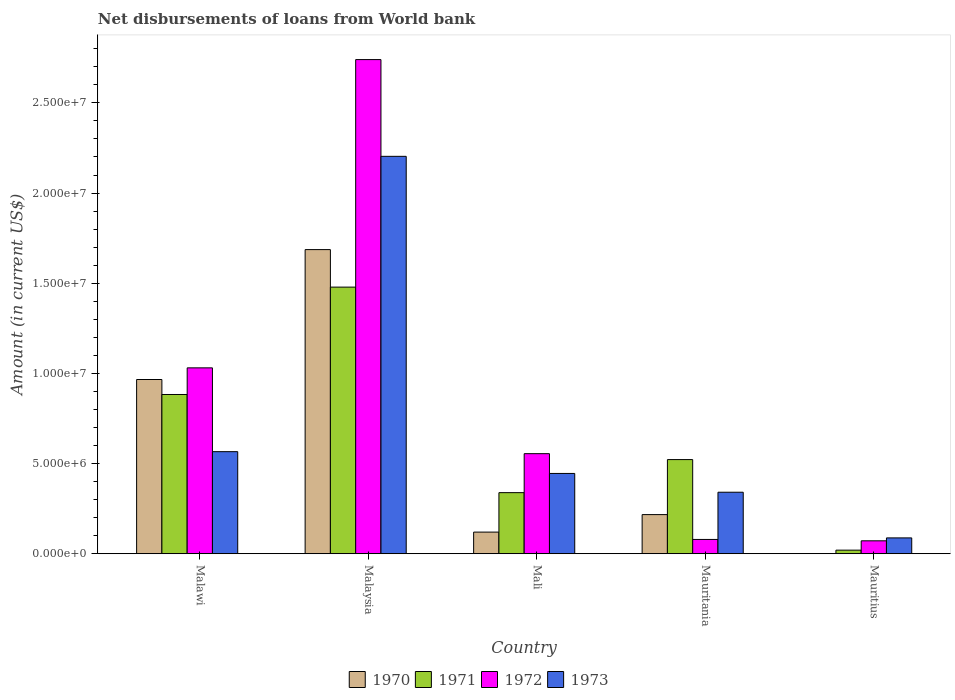Are the number of bars on each tick of the X-axis equal?
Offer a very short reply. No. How many bars are there on the 2nd tick from the left?
Provide a succinct answer. 4. How many bars are there on the 3rd tick from the right?
Keep it short and to the point. 4. What is the label of the 3rd group of bars from the left?
Your response must be concise. Mali. What is the amount of loan disbursed from World Bank in 1971 in Malaysia?
Provide a succinct answer. 1.48e+07. Across all countries, what is the maximum amount of loan disbursed from World Bank in 1972?
Provide a succinct answer. 2.74e+07. Across all countries, what is the minimum amount of loan disbursed from World Bank in 1970?
Offer a very short reply. 0. In which country was the amount of loan disbursed from World Bank in 1970 maximum?
Keep it short and to the point. Malaysia. What is the total amount of loan disbursed from World Bank in 1970 in the graph?
Offer a very short reply. 2.99e+07. What is the difference between the amount of loan disbursed from World Bank in 1970 in Malaysia and that in Mali?
Your answer should be very brief. 1.57e+07. What is the difference between the amount of loan disbursed from World Bank in 1971 in Mali and the amount of loan disbursed from World Bank in 1972 in Malawi?
Keep it short and to the point. -6.92e+06. What is the average amount of loan disbursed from World Bank in 1973 per country?
Make the answer very short. 7.29e+06. What is the difference between the amount of loan disbursed from World Bank of/in 1971 and amount of loan disbursed from World Bank of/in 1972 in Mauritius?
Ensure brevity in your answer.  -5.18e+05. In how many countries, is the amount of loan disbursed from World Bank in 1972 greater than 25000000 US$?
Provide a succinct answer. 1. What is the ratio of the amount of loan disbursed from World Bank in 1973 in Malawi to that in Mauritius?
Make the answer very short. 6.44. Is the amount of loan disbursed from World Bank in 1971 in Malaysia less than that in Mauritius?
Ensure brevity in your answer.  No. Is the difference between the amount of loan disbursed from World Bank in 1971 in Malaysia and Mauritania greater than the difference between the amount of loan disbursed from World Bank in 1972 in Malaysia and Mauritania?
Ensure brevity in your answer.  No. What is the difference between the highest and the second highest amount of loan disbursed from World Bank in 1972?
Your answer should be compact. 1.71e+07. What is the difference between the highest and the lowest amount of loan disbursed from World Bank in 1971?
Offer a very short reply. 1.46e+07. In how many countries, is the amount of loan disbursed from World Bank in 1972 greater than the average amount of loan disbursed from World Bank in 1972 taken over all countries?
Give a very brief answer. 2. Is it the case that in every country, the sum of the amount of loan disbursed from World Bank in 1971 and amount of loan disbursed from World Bank in 1970 is greater than the sum of amount of loan disbursed from World Bank in 1972 and amount of loan disbursed from World Bank in 1973?
Provide a succinct answer. No. Is it the case that in every country, the sum of the amount of loan disbursed from World Bank in 1970 and amount of loan disbursed from World Bank in 1972 is greater than the amount of loan disbursed from World Bank in 1973?
Offer a very short reply. No. Are all the bars in the graph horizontal?
Give a very brief answer. No. What is the difference between two consecutive major ticks on the Y-axis?
Your response must be concise. 5.00e+06. Does the graph contain any zero values?
Provide a short and direct response. Yes. Does the graph contain grids?
Provide a short and direct response. No. How are the legend labels stacked?
Your answer should be very brief. Horizontal. What is the title of the graph?
Keep it short and to the point. Net disbursements of loans from World bank. What is the label or title of the X-axis?
Give a very brief answer. Country. What is the label or title of the Y-axis?
Offer a terse response. Amount (in current US$). What is the Amount (in current US$) of 1970 in Malawi?
Keep it short and to the point. 9.66e+06. What is the Amount (in current US$) in 1971 in Malawi?
Make the answer very short. 8.83e+06. What is the Amount (in current US$) of 1972 in Malawi?
Give a very brief answer. 1.03e+07. What is the Amount (in current US$) in 1973 in Malawi?
Your response must be concise. 5.66e+06. What is the Amount (in current US$) in 1970 in Malaysia?
Your answer should be very brief. 1.69e+07. What is the Amount (in current US$) of 1971 in Malaysia?
Ensure brevity in your answer.  1.48e+07. What is the Amount (in current US$) of 1972 in Malaysia?
Offer a very short reply. 2.74e+07. What is the Amount (in current US$) of 1973 in Malaysia?
Your answer should be very brief. 2.20e+07. What is the Amount (in current US$) of 1970 in Mali?
Your answer should be very brief. 1.20e+06. What is the Amount (in current US$) of 1971 in Mali?
Your answer should be compact. 3.39e+06. What is the Amount (in current US$) of 1972 in Mali?
Offer a very short reply. 5.55e+06. What is the Amount (in current US$) of 1973 in Mali?
Give a very brief answer. 4.45e+06. What is the Amount (in current US$) of 1970 in Mauritania?
Provide a short and direct response. 2.17e+06. What is the Amount (in current US$) of 1971 in Mauritania?
Offer a very short reply. 5.22e+06. What is the Amount (in current US$) of 1972 in Mauritania?
Ensure brevity in your answer.  7.93e+05. What is the Amount (in current US$) of 1973 in Mauritania?
Make the answer very short. 3.41e+06. What is the Amount (in current US$) in 1971 in Mauritius?
Keep it short and to the point. 1.99e+05. What is the Amount (in current US$) in 1972 in Mauritius?
Ensure brevity in your answer.  7.17e+05. What is the Amount (in current US$) of 1973 in Mauritius?
Offer a terse response. 8.79e+05. Across all countries, what is the maximum Amount (in current US$) of 1970?
Ensure brevity in your answer.  1.69e+07. Across all countries, what is the maximum Amount (in current US$) in 1971?
Provide a short and direct response. 1.48e+07. Across all countries, what is the maximum Amount (in current US$) of 1972?
Your answer should be very brief. 2.74e+07. Across all countries, what is the maximum Amount (in current US$) in 1973?
Your response must be concise. 2.20e+07. Across all countries, what is the minimum Amount (in current US$) in 1970?
Give a very brief answer. 0. Across all countries, what is the minimum Amount (in current US$) of 1971?
Your answer should be very brief. 1.99e+05. Across all countries, what is the minimum Amount (in current US$) of 1972?
Your response must be concise. 7.17e+05. Across all countries, what is the minimum Amount (in current US$) of 1973?
Your response must be concise. 8.79e+05. What is the total Amount (in current US$) in 1970 in the graph?
Keep it short and to the point. 2.99e+07. What is the total Amount (in current US$) of 1971 in the graph?
Make the answer very short. 3.24e+07. What is the total Amount (in current US$) in 1972 in the graph?
Offer a terse response. 4.48e+07. What is the total Amount (in current US$) in 1973 in the graph?
Your response must be concise. 3.64e+07. What is the difference between the Amount (in current US$) of 1970 in Malawi and that in Malaysia?
Your answer should be very brief. -7.20e+06. What is the difference between the Amount (in current US$) of 1971 in Malawi and that in Malaysia?
Give a very brief answer. -5.95e+06. What is the difference between the Amount (in current US$) of 1972 in Malawi and that in Malaysia?
Keep it short and to the point. -1.71e+07. What is the difference between the Amount (in current US$) in 1973 in Malawi and that in Malaysia?
Your answer should be very brief. -1.64e+07. What is the difference between the Amount (in current US$) of 1970 in Malawi and that in Mali?
Make the answer very short. 8.46e+06. What is the difference between the Amount (in current US$) of 1971 in Malawi and that in Mali?
Your response must be concise. 5.44e+06. What is the difference between the Amount (in current US$) of 1972 in Malawi and that in Mali?
Your answer should be compact. 4.76e+06. What is the difference between the Amount (in current US$) in 1973 in Malawi and that in Mali?
Give a very brief answer. 1.21e+06. What is the difference between the Amount (in current US$) of 1970 in Malawi and that in Mauritania?
Your answer should be very brief. 7.49e+06. What is the difference between the Amount (in current US$) in 1971 in Malawi and that in Mauritania?
Provide a short and direct response. 3.61e+06. What is the difference between the Amount (in current US$) in 1972 in Malawi and that in Mauritania?
Your response must be concise. 9.51e+06. What is the difference between the Amount (in current US$) in 1973 in Malawi and that in Mauritania?
Offer a very short reply. 2.25e+06. What is the difference between the Amount (in current US$) in 1971 in Malawi and that in Mauritius?
Make the answer very short. 8.63e+06. What is the difference between the Amount (in current US$) in 1972 in Malawi and that in Mauritius?
Your response must be concise. 9.59e+06. What is the difference between the Amount (in current US$) in 1973 in Malawi and that in Mauritius?
Your answer should be very brief. 4.78e+06. What is the difference between the Amount (in current US$) of 1970 in Malaysia and that in Mali?
Provide a succinct answer. 1.57e+07. What is the difference between the Amount (in current US$) in 1971 in Malaysia and that in Mali?
Ensure brevity in your answer.  1.14e+07. What is the difference between the Amount (in current US$) of 1972 in Malaysia and that in Mali?
Your response must be concise. 2.19e+07. What is the difference between the Amount (in current US$) of 1973 in Malaysia and that in Mali?
Offer a terse response. 1.76e+07. What is the difference between the Amount (in current US$) in 1970 in Malaysia and that in Mauritania?
Your answer should be compact. 1.47e+07. What is the difference between the Amount (in current US$) in 1971 in Malaysia and that in Mauritania?
Keep it short and to the point. 9.56e+06. What is the difference between the Amount (in current US$) in 1972 in Malaysia and that in Mauritania?
Provide a succinct answer. 2.66e+07. What is the difference between the Amount (in current US$) in 1973 in Malaysia and that in Mauritania?
Offer a very short reply. 1.86e+07. What is the difference between the Amount (in current US$) of 1971 in Malaysia and that in Mauritius?
Your response must be concise. 1.46e+07. What is the difference between the Amount (in current US$) in 1972 in Malaysia and that in Mauritius?
Provide a succinct answer. 2.67e+07. What is the difference between the Amount (in current US$) in 1973 in Malaysia and that in Mauritius?
Ensure brevity in your answer.  2.12e+07. What is the difference between the Amount (in current US$) of 1970 in Mali and that in Mauritania?
Give a very brief answer. -9.70e+05. What is the difference between the Amount (in current US$) in 1971 in Mali and that in Mauritania?
Offer a terse response. -1.83e+06. What is the difference between the Amount (in current US$) in 1972 in Mali and that in Mauritania?
Your response must be concise. 4.76e+06. What is the difference between the Amount (in current US$) in 1973 in Mali and that in Mauritania?
Your answer should be compact. 1.04e+06. What is the difference between the Amount (in current US$) in 1971 in Mali and that in Mauritius?
Your answer should be compact. 3.19e+06. What is the difference between the Amount (in current US$) of 1972 in Mali and that in Mauritius?
Provide a short and direct response. 4.83e+06. What is the difference between the Amount (in current US$) in 1973 in Mali and that in Mauritius?
Offer a very short reply. 3.57e+06. What is the difference between the Amount (in current US$) in 1971 in Mauritania and that in Mauritius?
Ensure brevity in your answer.  5.02e+06. What is the difference between the Amount (in current US$) of 1972 in Mauritania and that in Mauritius?
Provide a short and direct response. 7.60e+04. What is the difference between the Amount (in current US$) in 1973 in Mauritania and that in Mauritius?
Provide a short and direct response. 2.53e+06. What is the difference between the Amount (in current US$) of 1970 in Malawi and the Amount (in current US$) of 1971 in Malaysia?
Provide a succinct answer. -5.12e+06. What is the difference between the Amount (in current US$) of 1970 in Malawi and the Amount (in current US$) of 1972 in Malaysia?
Your answer should be compact. -1.77e+07. What is the difference between the Amount (in current US$) in 1970 in Malawi and the Amount (in current US$) in 1973 in Malaysia?
Give a very brief answer. -1.24e+07. What is the difference between the Amount (in current US$) of 1971 in Malawi and the Amount (in current US$) of 1972 in Malaysia?
Your answer should be very brief. -1.86e+07. What is the difference between the Amount (in current US$) of 1971 in Malawi and the Amount (in current US$) of 1973 in Malaysia?
Your response must be concise. -1.32e+07. What is the difference between the Amount (in current US$) of 1972 in Malawi and the Amount (in current US$) of 1973 in Malaysia?
Your answer should be compact. -1.17e+07. What is the difference between the Amount (in current US$) of 1970 in Malawi and the Amount (in current US$) of 1971 in Mali?
Provide a short and direct response. 6.27e+06. What is the difference between the Amount (in current US$) of 1970 in Malawi and the Amount (in current US$) of 1972 in Mali?
Keep it short and to the point. 4.11e+06. What is the difference between the Amount (in current US$) of 1970 in Malawi and the Amount (in current US$) of 1973 in Mali?
Offer a very short reply. 5.21e+06. What is the difference between the Amount (in current US$) in 1971 in Malawi and the Amount (in current US$) in 1972 in Mali?
Give a very brief answer. 3.28e+06. What is the difference between the Amount (in current US$) in 1971 in Malawi and the Amount (in current US$) in 1973 in Mali?
Your response must be concise. 4.38e+06. What is the difference between the Amount (in current US$) of 1972 in Malawi and the Amount (in current US$) of 1973 in Mali?
Make the answer very short. 5.86e+06. What is the difference between the Amount (in current US$) of 1970 in Malawi and the Amount (in current US$) of 1971 in Mauritania?
Ensure brevity in your answer.  4.44e+06. What is the difference between the Amount (in current US$) of 1970 in Malawi and the Amount (in current US$) of 1972 in Mauritania?
Provide a short and direct response. 8.87e+06. What is the difference between the Amount (in current US$) of 1970 in Malawi and the Amount (in current US$) of 1973 in Mauritania?
Your answer should be compact. 6.25e+06. What is the difference between the Amount (in current US$) of 1971 in Malawi and the Amount (in current US$) of 1972 in Mauritania?
Make the answer very short. 8.04e+06. What is the difference between the Amount (in current US$) of 1971 in Malawi and the Amount (in current US$) of 1973 in Mauritania?
Your response must be concise. 5.42e+06. What is the difference between the Amount (in current US$) of 1972 in Malawi and the Amount (in current US$) of 1973 in Mauritania?
Keep it short and to the point. 6.90e+06. What is the difference between the Amount (in current US$) of 1970 in Malawi and the Amount (in current US$) of 1971 in Mauritius?
Your answer should be compact. 9.46e+06. What is the difference between the Amount (in current US$) in 1970 in Malawi and the Amount (in current US$) in 1972 in Mauritius?
Offer a terse response. 8.94e+06. What is the difference between the Amount (in current US$) of 1970 in Malawi and the Amount (in current US$) of 1973 in Mauritius?
Offer a very short reply. 8.78e+06. What is the difference between the Amount (in current US$) in 1971 in Malawi and the Amount (in current US$) in 1972 in Mauritius?
Provide a short and direct response. 8.11e+06. What is the difference between the Amount (in current US$) of 1971 in Malawi and the Amount (in current US$) of 1973 in Mauritius?
Provide a short and direct response. 7.95e+06. What is the difference between the Amount (in current US$) in 1972 in Malawi and the Amount (in current US$) in 1973 in Mauritius?
Offer a very short reply. 9.43e+06. What is the difference between the Amount (in current US$) in 1970 in Malaysia and the Amount (in current US$) in 1971 in Mali?
Your response must be concise. 1.35e+07. What is the difference between the Amount (in current US$) in 1970 in Malaysia and the Amount (in current US$) in 1972 in Mali?
Offer a terse response. 1.13e+07. What is the difference between the Amount (in current US$) in 1970 in Malaysia and the Amount (in current US$) in 1973 in Mali?
Offer a very short reply. 1.24e+07. What is the difference between the Amount (in current US$) in 1971 in Malaysia and the Amount (in current US$) in 1972 in Mali?
Your response must be concise. 9.24e+06. What is the difference between the Amount (in current US$) of 1971 in Malaysia and the Amount (in current US$) of 1973 in Mali?
Provide a succinct answer. 1.03e+07. What is the difference between the Amount (in current US$) in 1972 in Malaysia and the Amount (in current US$) in 1973 in Mali?
Your answer should be very brief. 2.29e+07. What is the difference between the Amount (in current US$) in 1970 in Malaysia and the Amount (in current US$) in 1971 in Mauritania?
Provide a succinct answer. 1.16e+07. What is the difference between the Amount (in current US$) in 1970 in Malaysia and the Amount (in current US$) in 1972 in Mauritania?
Your response must be concise. 1.61e+07. What is the difference between the Amount (in current US$) in 1970 in Malaysia and the Amount (in current US$) in 1973 in Mauritania?
Give a very brief answer. 1.35e+07. What is the difference between the Amount (in current US$) in 1971 in Malaysia and the Amount (in current US$) in 1972 in Mauritania?
Your answer should be compact. 1.40e+07. What is the difference between the Amount (in current US$) of 1971 in Malaysia and the Amount (in current US$) of 1973 in Mauritania?
Offer a terse response. 1.14e+07. What is the difference between the Amount (in current US$) of 1972 in Malaysia and the Amount (in current US$) of 1973 in Mauritania?
Offer a terse response. 2.40e+07. What is the difference between the Amount (in current US$) in 1970 in Malaysia and the Amount (in current US$) in 1971 in Mauritius?
Your response must be concise. 1.67e+07. What is the difference between the Amount (in current US$) of 1970 in Malaysia and the Amount (in current US$) of 1972 in Mauritius?
Give a very brief answer. 1.61e+07. What is the difference between the Amount (in current US$) in 1970 in Malaysia and the Amount (in current US$) in 1973 in Mauritius?
Keep it short and to the point. 1.60e+07. What is the difference between the Amount (in current US$) in 1971 in Malaysia and the Amount (in current US$) in 1972 in Mauritius?
Ensure brevity in your answer.  1.41e+07. What is the difference between the Amount (in current US$) of 1971 in Malaysia and the Amount (in current US$) of 1973 in Mauritius?
Your answer should be compact. 1.39e+07. What is the difference between the Amount (in current US$) in 1972 in Malaysia and the Amount (in current US$) in 1973 in Mauritius?
Keep it short and to the point. 2.65e+07. What is the difference between the Amount (in current US$) in 1970 in Mali and the Amount (in current US$) in 1971 in Mauritania?
Your answer should be compact. -4.02e+06. What is the difference between the Amount (in current US$) in 1970 in Mali and the Amount (in current US$) in 1972 in Mauritania?
Make the answer very short. 4.07e+05. What is the difference between the Amount (in current US$) of 1970 in Mali and the Amount (in current US$) of 1973 in Mauritania?
Offer a terse response. -2.21e+06. What is the difference between the Amount (in current US$) in 1971 in Mali and the Amount (in current US$) in 1972 in Mauritania?
Offer a very short reply. 2.60e+06. What is the difference between the Amount (in current US$) of 1971 in Mali and the Amount (in current US$) of 1973 in Mauritania?
Make the answer very short. -2.30e+04. What is the difference between the Amount (in current US$) of 1972 in Mali and the Amount (in current US$) of 1973 in Mauritania?
Provide a short and direct response. 2.14e+06. What is the difference between the Amount (in current US$) of 1970 in Mali and the Amount (in current US$) of 1971 in Mauritius?
Provide a short and direct response. 1.00e+06. What is the difference between the Amount (in current US$) in 1970 in Mali and the Amount (in current US$) in 1972 in Mauritius?
Keep it short and to the point. 4.83e+05. What is the difference between the Amount (in current US$) of 1970 in Mali and the Amount (in current US$) of 1973 in Mauritius?
Give a very brief answer. 3.21e+05. What is the difference between the Amount (in current US$) in 1971 in Mali and the Amount (in current US$) in 1972 in Mauritius?
Provide a succinct answer. 2.67e+06. What is the difference between the Amount (in current US$) in 1971 in Mali and the Amount (in current US$) in 1973 in Mauritius?
Provide a succinct answer. 2.51e+06. What is the difference between the Amount (in current US$) in 1972 in Mali and the Amount (in current US$) in 1973 in Mauritius?
Keep it short and to the point. 4.67e+06. What is the difference between the Amount (in current US$) in 1970 in Mauritania and the Amount (in current US$) in 1971 in Mauritius?
Provide a succinct answer. 1.97e+06. What is the difference between the Amount (in current US$) of 1970 in Mauritania and the Amount (in current US$) of 1972 in Mauritius?
Provide a succinct answer. 1.45e+06. What is the difference between the Amount (in current US$) in 1970 in Mauritania and the Amount (in current US$) in 1973 in Mauritius?
Your response must be concise. 1.29e+06. What is the difference between the Amount (in current US$) in 1971 in Mauritania and the Amount (in current US$) in 1972 in Mauritius?
Your response must be concise. 4.50e+06. What is the difference between the Amount (in current US$) of 1971 in Mauritania and the Amount (in current US$) of 1973 in Mauritius?
Your answer should be compact. 4.34e+06. What is the difference between the Amount (in current US$) in 1972 in Mauritania and the Amount (in current US$) in 1973 in Mauritius?
Your answer should be compact. -8.60e+04. What is the average Amount (in current US$) of 1970 per country?
Keep it short and to the point. 5.98e+06. What is the average Amount (in current US$) in 1971 per country?
Provide a short and direct response. 6.48e+06. What is the average Amount (in current US$) in 1972 per country?
Make the answer very short. 8.95e+06. What is the average Amount (in current US$) in 1973 per country?
Give a very brief answer. 7.29e+06. What is the difference between the Amount (in current US$) of 1970 and Amount (in current US$) of 1971 in Malawi?
Ensure brevity in your answer.  8.31e+05. What is the difference between the Amount (in current US$) in 1970 and Amount (in current US$) in 1972 in Malawi?
Offer a very short reply. -6.46e+05. What is the difference between the Amount (in current US$) in 1970 and Amount (in current US$) in 1973 in Malawi?
Your answer should be compact. 4.00e+06. What is the difference between the Amount (in current US$) of 1971 and Amount (in current US$) of 1972 in Malawi?
Offer a very short reply. -1.48e+06. What is the difference between the Amount (in current US$) in 1971 and Amount (in current US$) in 1973 in Malawi?
Your answer should be compact. 3.17e+06. What is the difference between the Amount (in current US$) in 1972 and Amount (in current US$) in 1973 in Malawi?
Ensure brevity in your answer.  4.65e+06. What is the difference between the Amount (in current US$) of 1970 and Amount (in current US$) of 1971 in Malaysia?
Provide a short and direct response. 2.08e+06. What is the difference between the Amount (in current US$) in 1970 and Amount (in current US$) in 1972 in Malaysia?
Offer a very short reply. -1.05e+07. What is the difference between the Amount (in current US$) of 1970 and Amount (in current US$) of 1973 in Malaysia?
Provide a short and direct response. -5.17e+06. What is the difference between the Amount (in current US$) in 1971 and Amount (in current US$) in 1972 in Malaysia?
Keep it short and to the point. -1.26e+07. What is the difference between the Amount (in current US$) of 1971 and Amount (in current US$) of 1973 in Malaysia?
Provide a succinct answer. -7.25e+06. What is the difference between the Amount (in current US$) in 1972 and Amount (in current US$) in 1973 in Malaysia?
Your answer should be compact. 5.36e+06. What is the difference between the Amount (in current US$) of 1970 and Amount (in current US$) of 1971 in Mali?
Provide a succinct answer. -2.19e+06. What is the difference between the Amount (in current US$) of 1970 and Amount (in current US$) of 1972 in Mali?
Make the answer very short. -4.35e+06. What is the difference between the Amount (in current US$) in 1970 and Amount (in current US$) in 1973 in Mali?
Provide a short and direct response. -3.25e+06. What is the difference between the Amount (in current US$) of 1971 and Amount (in current US$) of 1972 in Mali?
Your response must be concise. -2.16e+06. What is the difference between the Amount (in current US$) in 1971 and Amount (in current US$) in 1973 in Mali?
Your answer should be very brief. -1.06e+06. What is the difference between the Amount (in current US$) of 1972 and Amount (in current US$) of 1973 in Mali?
Provide a succinct answer. 1.10e+06. What is the difference between the Amount (in current US$) of 1970 and Amount (in current US$) of 1971 in Mauritania?
Provide a succinct answer. -3.05e+06. What is the difference between the Amount (in current US$) of 1970 and Amount (in current US$) of 1972 in Mauritania?
Keep it short and to the point. 1.38e+06. What is the difference between the Amount (in current US$) of 1970 and Amount (in current US$) of 1973 in Mauritania?
Offer a terse response. -1.24e+06. What is the difference between the Amount (in current US$) of 1971 and Amount (in current US$) of 1972 in Mauritania?
Keep it short and to the point. 4.43e+06. What is the difference between the Amount (in current US$) in 1971 and Amount (in current US$) in 1973 in Mauritania?
Offer a very short reply. 1.81e+06. What is the difference between the Amount (in current US$) in 1972 and Amount (in current US$) in 1973 in Mauritania?
Offer a terse response. -2.62e+06. What is the difference between the Amount (in current US$) in 1971 and Amount (in current US$) in 1972 in Mauritius?
Ensure brevity in your answer.  -5.18e+05. What is the difference between the Amount (in current US$) in 1971 and Amount (in current US$) in 1973 in Mauritius?
Offer a terse response. -6.80e+05. What is the difference between the Amount (in current US$) of 1972 and Amount (in current US$) of 1973 in Mauritius?
Offer a terse response. -1.62e+05. What is the ratio of the Amount (in current US$) of 1970 in Malawi to that in Malaysia?
Your response must be concise. 0.57. What is the ratio of the Amount (in current US$) of 1971 in Malawi to that in Malaysia?
Your answer should be very brief. 0.6. What is the ratio of the Amount (in current US$) of 1972 in Malawi to that in Malaysia?
Offer a very short reply. 0.38. What is the ratio of the Amount (in current US$) of 1973 in Malawi to that in Malaysia?
Ensure brevity in your answer.  0.26. What is the ratio of the Amount (in current US$) of 1970 in Malawi to that in Mali?
Make the answer very short. 8.05. What is the ratio of the Amount (in current US$) in 1971 in Malawi to that in Mali?
Your answer should be very brief. 2.61. What is the ratio of the Amount (in current US$) of 1972 in Malawi to that in Mali?
Offer a very short reply. 1.86. What is the ratio of the Amount (in current US$) of 1973 in Malawi to that in Mali?
Offer a very short reply. 1.27. What is the ratio of the Amount (in current US$) in 1970 in Malawi to that in Mauritania?
Offer a very short reply. 4.45. What is the ratio of the Amount (in current US$) in 1971 in Malawi to that in Mauritania?
Offer a terse response. 1.69. What is the ratio of the Amount (in current US$) of 1972 in Malawi to that in Mauritania?
Ensure brevity in your answer.  13. What is the ratio of the Amount (in current US$) of 1973 in Malawi to that in Mauritania?
Your response must be concise. 1.66. What is the ratio of the Amount (in current US$) in 1971 in Malawi to that in Mauritius?
Provide a succinct answer. 44.37. What is the ratio of the Amount (in current US$) of 1972 in Malawi to that in Mauritius?
Keep it short and to the point. 14.38. What is the ratio of the Amount (in current US$) of 1973 in Malawi to that in Mauritius?
Provide a succinct answer. 6.44. What is the ratio of the Amount (in current US$) in 1970 in Malaysia to that in Mali?
Your response must be concise. 14.05. What is the ratio of the Amount (in current US$) of 1971 in Malaysia to that in Mali?
Your answer should be very brief. 4.36. What is the ratio of the Amount (in current US$) of 1972 in Malaysia to that in Mali?
Offer a very short reply. 4.94. What is the ratio of the Amount (in current US$) of 1973 in Malaysia to that in Mali?
Make the answer very short. 4.95. What is the ratio of the Amount (in current US$) in 1970 in Malaysia to that in Mauritania?
Provide a short and direct response. 7.77. What is the ratio of the Amount (in current US$) in 1971 in Malaysia to that in Mauritania?
Offer a terse response. 2.83. What is the ratio of the Amount (in current US$) in 1972 in Malaysia to that in Mauritania?
Your answer should be very brief. 34.55. What is the ratio of the Amount (in current US$) of 1973 in Malaysia to that in Mauritania?
Offer a terse response. 6.46. What is the ratio of the Amount (in current US$) of 1971 in Malaysia to that in Mauritius?
Offer a terse response. 74.29. What is the ratio of the Amount (in current US$) of 1972 in Malaysia to that in Mauritius?
Give a very brief answer. 38.21. What is the ratio of the Amount (in current US$) of 1973 in Malaysia to that in Mauritius?
Make the answer very short. 25.07. What is the ratio of the Amount (in current US$) in 1970 in Mali to that in Mauritania?
Provide a short and direct response. 0.55. What is the ratio of the Amount (in current US$) of 1971 in Mali to that in Mauritania?
Your answer should be very brief. 0.65. What is the ratio of the Amount (in current US$) of 1972 in Mali to that in Mauritania?
Keep it short and to the point. 7. What is the ratio of the Amount (in current US$) of 1973 in Mali to that in Mauritania?
Offer a very short reply. 1.31. What is the ratio of the Amount (in current US$) of 1971 in Mali to that in Mauritius?
Make the answer very short. 17.03. What is the ratio of the Amount (in current US$) of 1972 in Mali to that in Mauritius?
Provide a short and direct response. 7.74. What is the ratio of the Amount (in current US$) of 1973 in Mali to that in Mauritius?
Make the answer very short. 5.06. What is the ratio of the Amount (in current US$) in 1971 in Mauritania to that in Mauritius?
Provide a short and direct response. 26.24. What is the ratio of the Amount (in current US$) in 1972 in Mauritania to that in Mauritius?
Your response must be concise. 1.11. What is the ratio of the Amount (in current US$) in 1973 in Mauritania to that in Mauritius?
Your answer should be very brief. 3.88. What is the difference between the highest and the second highest Amount (in current US$) in 1970?
Offer a terse response. 7.20e+06. What is the difference between the highest and the second highest Amount (in current US$) in 1971?
Keep it short and to the point. 5.95e+06. What is the difference between the highest and the second highest Amount (in current US$) of 1972?
Ensure brevity in your answer.  1.71e+07. What is the difference between the highest and the second highest Amount (in current US$) in 1973?
Your answer should be compact. 1.64e+07. What is the difference between the highest and the lowest Amount (in current US$) in 1970?
Keep it short and to the point. 1.69e+07. What is the difference between the highest and the lowest Amount (in current US$) of 1971?
Offer a terse response. 1.46e+07. What is the difference between the highest and the lowest Amount (in current US$) in 1972?
Offer a terse response. 2.67e+07. What is the difference between the highest and the lowest Amount (in current US$) of 1973?
Offer a very short reply. 2.12e+07. 